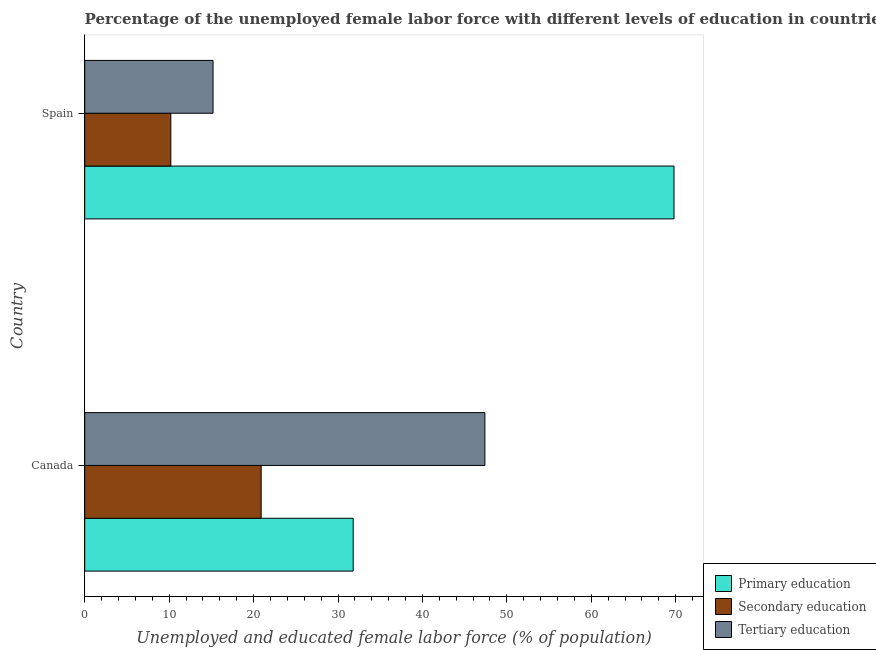How many groups of bars are there?
Ensure brevity in your answer.  2. What is the percentage of female labor force who received secondary education in Spain?
Your answer should be very brief. 10.2. Across all countries, what is the maximum percentage of female labor force who received tertiary education?
Make the answer very short. 47.4. Across all countries, what is the minimum percentage of female labor force who received tertiary education?
Your response must be concise. 15.2. What is the total percentage of female labor force who received secondary education in the graph?
Provide a short and direct response. 31.1. What is the difference between the percentage of female labor force who received primary education in Canada and that in Spain?
Your answer should be very brief. -38. What is the difference between the percentage of female labor force who received secondary education in Canada and the percentage of female labor force who received tertiary education in Spain?
Provide a succinct answer. 5.7. What is the average percentage of female labor force who received secondary education per country?
Ensure brevity in your answer.  15.55. What is the difference between the percentage of female labor force who received primary education and percentage of female labor force who received secondary education in Spain?
Ensure brevity in your answer.  59.6. What is the ratio of the percentage of female labor force who received tertiary education in Canada to that in Spain?
Make the answer very short. 3.12. What does the 1st bar from the top in Canada represents?
Your answer should be compact. Tertiary education. What does the 3rd bar from the bottom in Spain represents?
Your response must be concise. Tertiary education. Is it the case that in every country, the sum of the percentage of female labor force who received primary education and percentage of female labor force who received secondary education is greater than the percentage of female labor force who received tertiary education?
Your response must be concise. Yes. Are all the bars in the graph horizontal?
Your response must be concise. Yes. Are the values on the major ticks of X-axis written in scientific E-notation?
Provide a succinct answer. No. Where does the legend appear in the graph?
Offer a terse response. Bottom right. How are the legend labels stacked?
Offer a terse response. Vertical. What is the title of the graph?
Your response must be concise. Percentage of the unemployed female labor force with different levels of education in countries. What is the label or title of the X-axis?
Make the answer very short. Unemployed and educated female labor force (% of population). What is the Unemployed and educated female labor force (% of population) of Primary education in Canada?
Offer a terse response. 31.8. What is the Unemployed and educated female labor force (% of population) of Secondary education in Canada?
Provide a short and direct response. 20.9. What is the Unemployed and educated female labor force (% of population) of Tertiary education in Canada?
Provide a short and direct response. 47.4. What is the Unemployed and educated female labor force (% of population) of Primary education in Spain?
Provide a succinct answer. 69.8. What is the Unemployed and educated female labor force (% of population) of Secondary education in Spain?
Ensure brevity in your answer.  10.2. What is the Unemployed and educated female labor force (% of population) of Tertiary education in Spain?
Your answer should be compact. 15.2. Across all countries, what is the maximum Unemployed and educated female labor force (% of population) in Primary education?
Provide a short and direct response. 69.8. Across all countries, what is the maximum Unemployed and educated female labor force (% of population) in Secondary education?
Your response must be concise. 20.9. Across all countries, what is the maximum Unemployed and educated female labor force (% of population) of Tertiary education?
Ensure brevity in your answer.  47.4. Across all countries, what is the minimum Unemployed and educated female labor force (% of population) of Primary education?
Ensure brevity in your answer.  31.8. Across all countries, what is the minimum Unemployed and educated female labor force (% of population) in Secondary education?
Your answer should be compact. 10.2. Across all countries, what is the minimum Unemployed and educated female labor force (% of population) in Tertiary education?
Your answer should be compact. 15.2. What is the total Unemployed and educated female labor force (% of population) of Primary education in the graph?
Provide a short and direct response. 101.6. What is the total Unemployed and educated female labor force (% of population) of Secondary education in the graph?
Ensure brevity in your answer.  31.1. What is the total Unemployed and educated female labor force (% of population) of Tertiary education in the graph?
Your response must be concise. 62.6. What is the difference between the Unemployed and educated female labor force (% of population) of Primary education in Canada and that in Spain?
Provide a succinct answer. -38. What is the difference between the Unemployed and educated female labor force (% of population) in Tertiary education in Canada and that in Spain?
Keep it short and to the point. 32.2. What is the difference between the Unemployed and educated female labor force (% of population) of Primary education in Canada and the Unemployed and educated female labor force (% of population) of Secondary education in Spain?
Offer a very short reply. 21.6. What is the difference between the Unemployed and educated female labor force (% of population) in Secondary education in Canada and the Unemployed and educated female labor force (% of population) in Tertiary education in Spain?
Your response must be concise. 5.7. What is the average Unemployed and educated female labor force (% of population) in Primary education per country?
Give a very brief answer. 50.8. What is the average Unemployed and educated female labor force (% of population) in Secondary education per country?
Keep it short and to the point. 15.55. What is the average Unemployed and educated female labor force (% of population) in Tertiary education per country?
Keep it short and to the point. 31.3. What is the difference between the Unemployed and educated female labor force (% of population) of Primary education and Unemployed and educated female labor force (% of population) of Secondary education in Canada?
Ensure brevity in your answer.  10.9. What is the difference between the Unemployed and educated female labor force (% of population) in Primary education and Unemployed and educated female labor force (% of population) in Tertiary education in Canada?
Give a very brief answer. -15.6. What is the difference between the Unemployed and educated female labor force (% of population) in Secondary education and Unemployed and educated female labor force (% of population) in Tertiary education in Canada?
Keep it short and to the point. -26.5. What is the difference between the Unemployed and educated female labor force (% of population) of Primary education and Unemployed and educated female labor force (% of population) of Secondary education in Spain?
Offer a terse response. 59.6. What is the difference between the Unemployed and educated female labor force (% of population) of Primary education and Unemployed and educated female labor force (% of population) of Tertiary education in Spain?
Provide a succinct answer. 54.6. What is the ratio of the Unemployed and educated female labor force (% of population) in Primary education in Canada to that in Spain?
Your answer should be compact. 0.46. What is the ratio of the Unemployed and educated female labor force (% of population) of Secondary education in Canada to that in Spain?
Your answer should be compact. 2.05. What is the ratio of the Unemployed and educated female labor force (% of population) in Tertiary education in Canada to that in Spain?
Offer a terse response. 3.12. What is the difference between the highest and the second highest Unemployed and educated female labor force (% of population) of Primary education?
Offer a terse response. 38. What is the difference between the highest and the second highest Unemployed and educated female labor force (% of population) of Secondary education?
Offer a very short reply. 10.7. What is the difference between the highest and the second highest Unemployed and educated female labor force (% of population) in Tertiary education?
Ensure brevity in your answer.  32.2. What is the difference between the highest and the lowest Unemployed and educated female labor force (% of population) in Secondary education?
Ensure brevity in your answer.  10.7. What is the difference between the highest and the lowest Unemployed and educated female labor force (% of population) in Tertiary education?
Offer a very short reply. 32.2. 